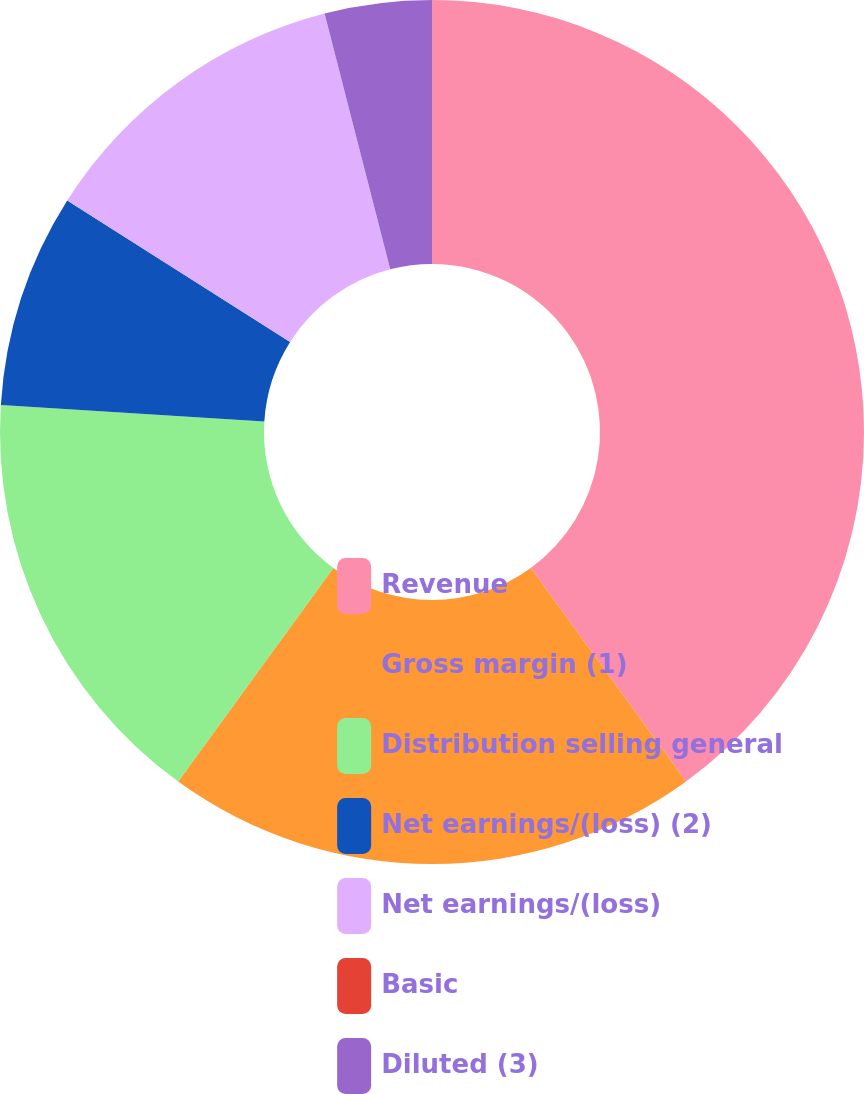<chart> <loc_0><loc_0><loc_500><loc_500><pie_chart><fcel>Revenue<fcel>Gross margin (1)<fcel>Distribution selling general<fcel>Net earnings/(loss) (2)<fcel>Net earnings/(loss)<fcel>Basic<fcel>Diluted (3)<nl><fcel>39.99%<fcel>20.0%<fcel>16.0%<fcel>8.0%<fcel>12.0%<fcel>0.0%<fcel>4.0%<nl></chart> 